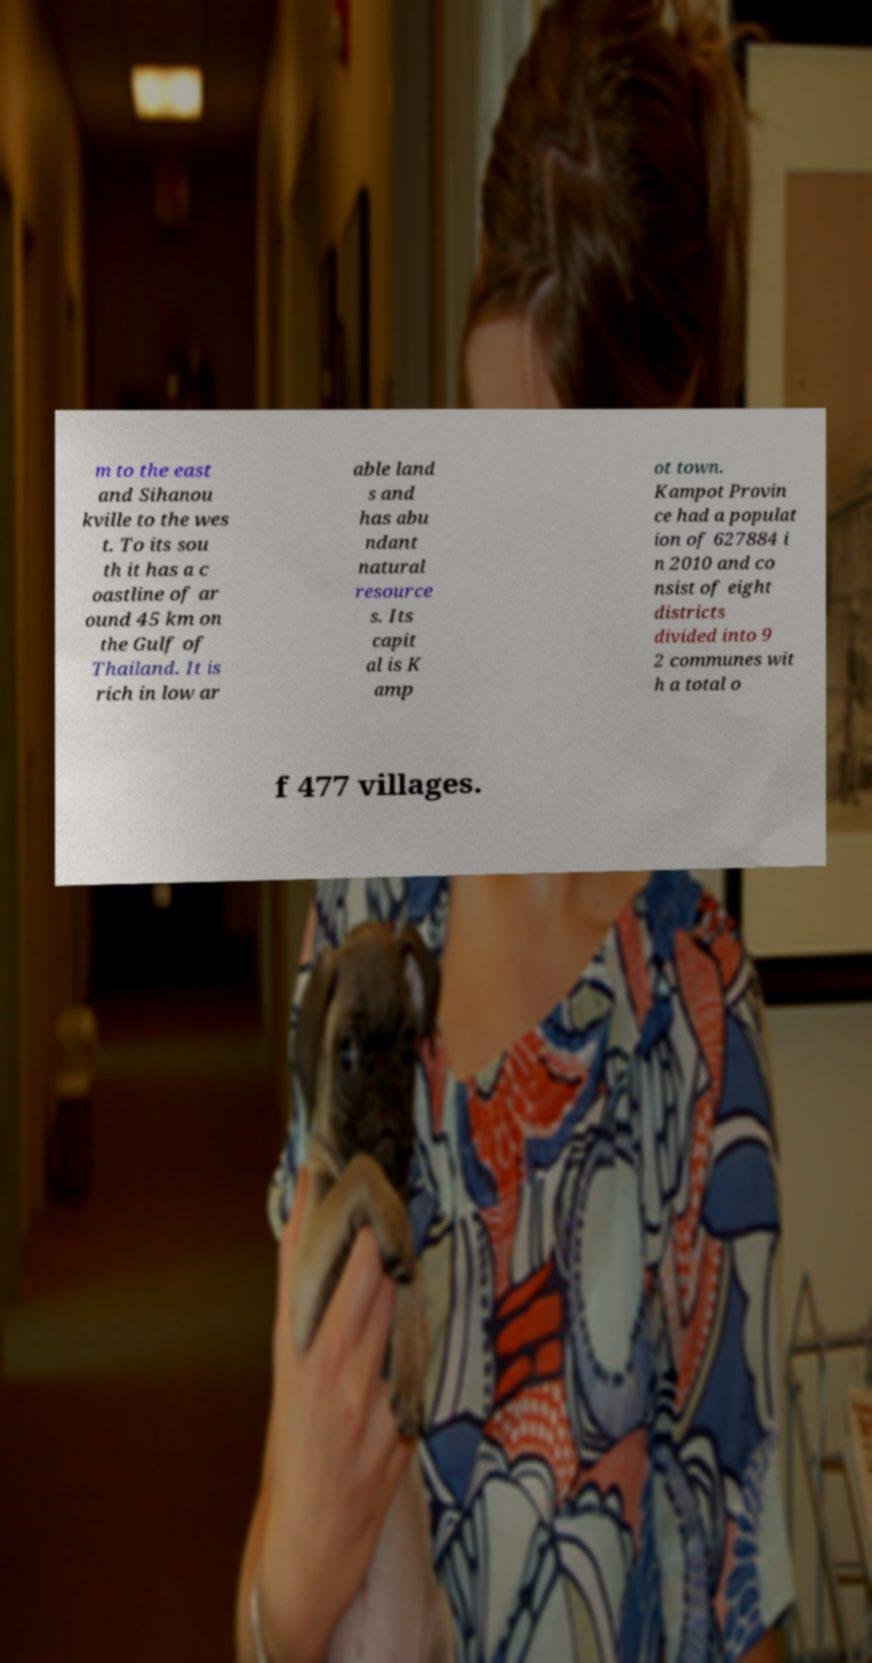Could you extract and type out the text from this image? m to the east and Sihanou kville to the wes t. To its sou th it has a c oastline of ar ound 45 km on the Gulf of Thailand. It is rich in low ar able land s and has abu ndant natural resource s. Its capit al is K amp ot town. Kampot Provin ce had a populat ion of 627884 i n 2010 and co nsist of eight districts divided into 9 2 communes wit h a total o f 477 villages. 